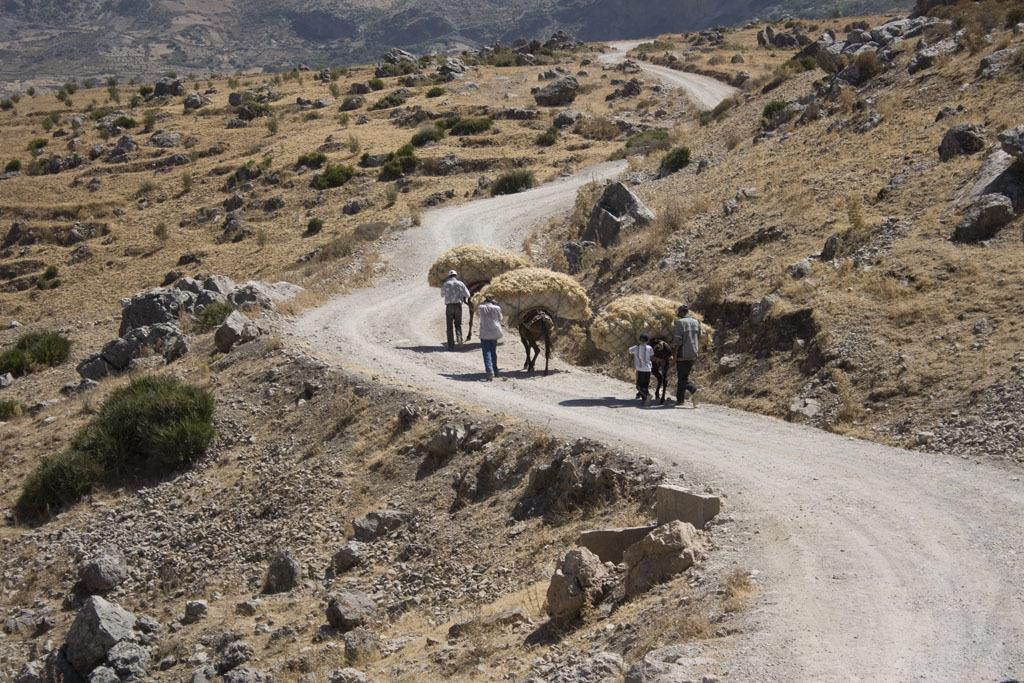Where was the image taken? The image was clicked outside. What type of vegetation can be seen in the image? There are bushes in the image. What is the main focus of the image? There are persons and animals in the middle of the image. What is on the animals in the image? There is something on the animals, which could be a harness, saddle, or other equipment. Can you find the key that was dropped by the person in the image? There is no key visible in the image, and it is not mentioned in the provided facts. 